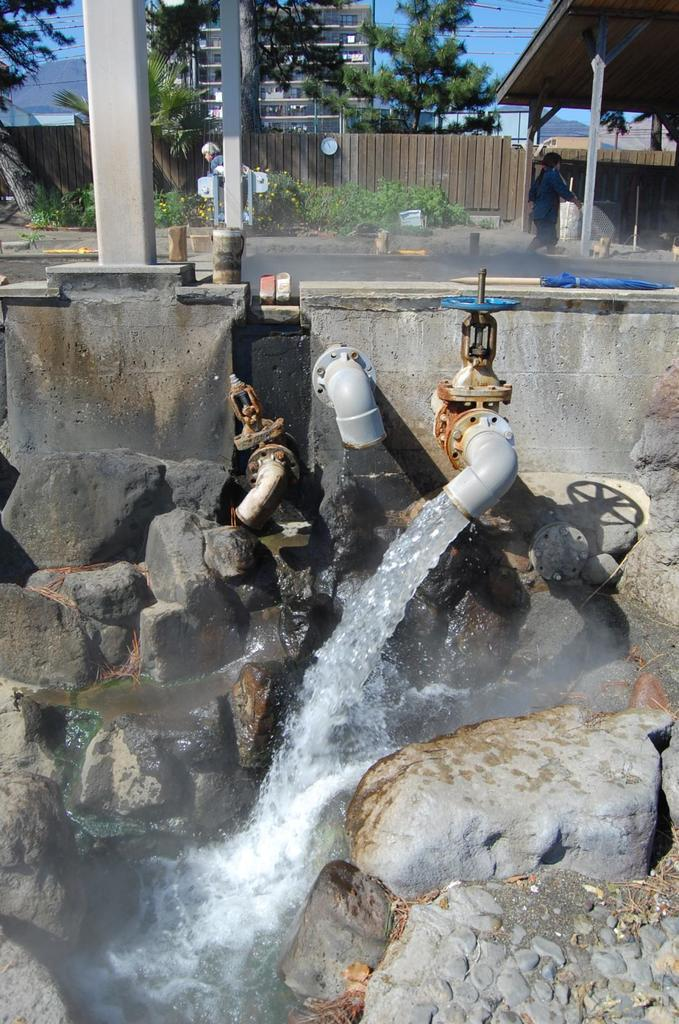What can be seen in the foreground of the picture? In the foreground of the picture, there are rocks, pipes, and water visible. What is located at the top of the picture? At the top of the picture, there are poles and sticks. What types of vegetation can be seen in the background of the picture? In the background of the picture, there are plants, trees, and buildings visible. What man-made structures are present in the background of the picture? In the background of the picture, there are buildings and a road visible. Is there any human presence in the picture? Yes, there is a person in the background of the picture. What type of question is being asked in the image? There is no question being asked in the image; it is a visual representation of a scene. Can you read the letters on the poles in the image? There are no letters visible on the poles in the image. 